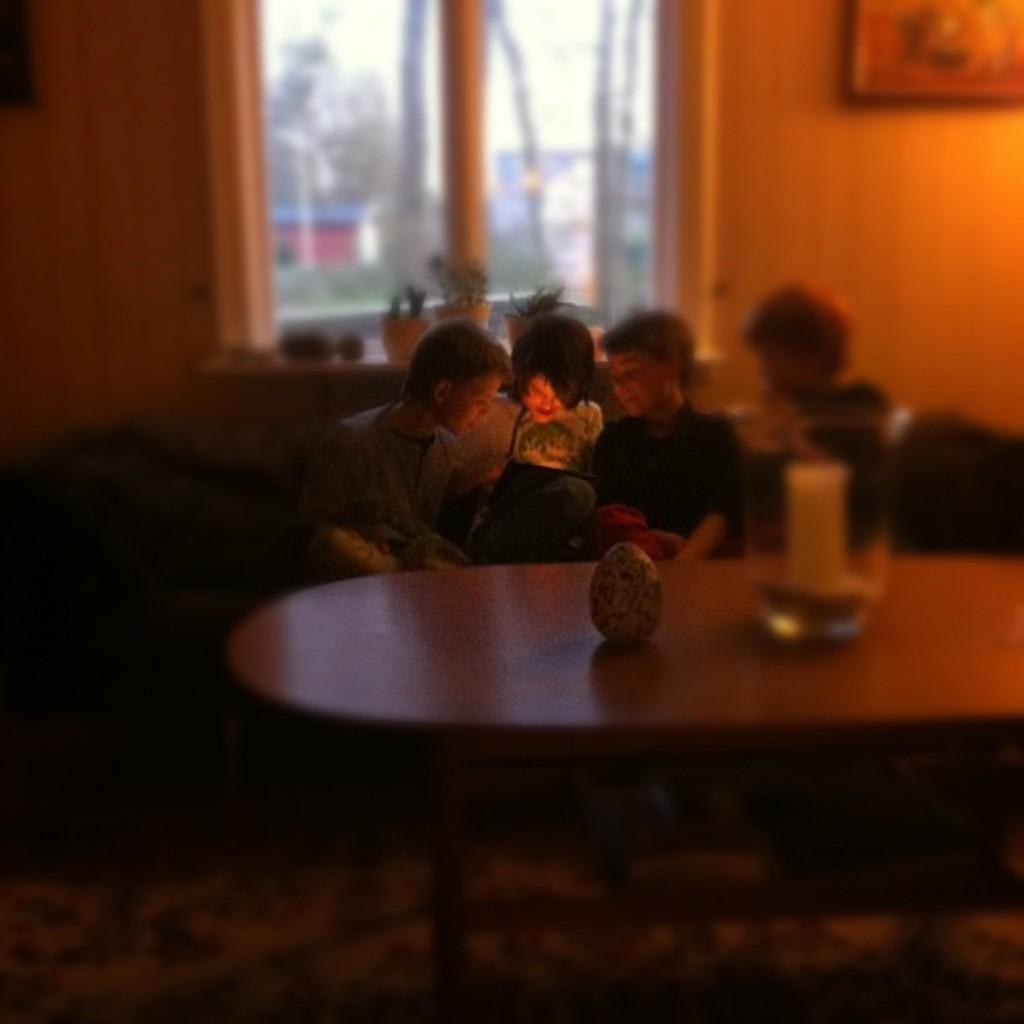Can you describe this image briefly? In this picture I can see people are sitting in front of a table. On the table I can see some objects. In the background I can see a window and a wall which has a photo attached to it. 